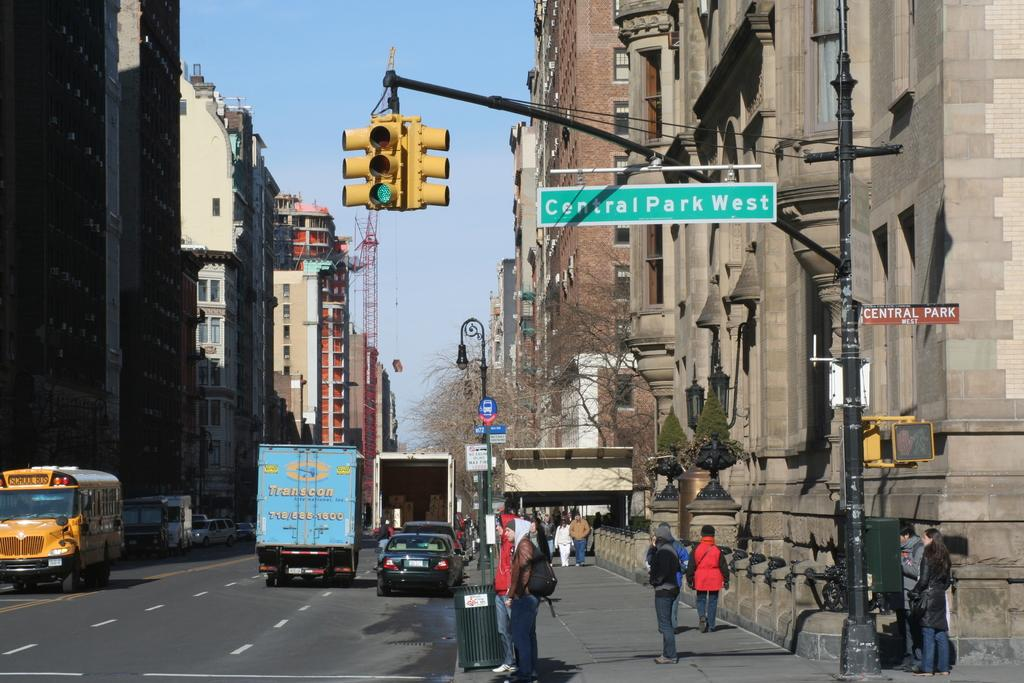Provide a one-sentence caption for the provided image. At intersections a street sign will tell the people around what street they are on. 